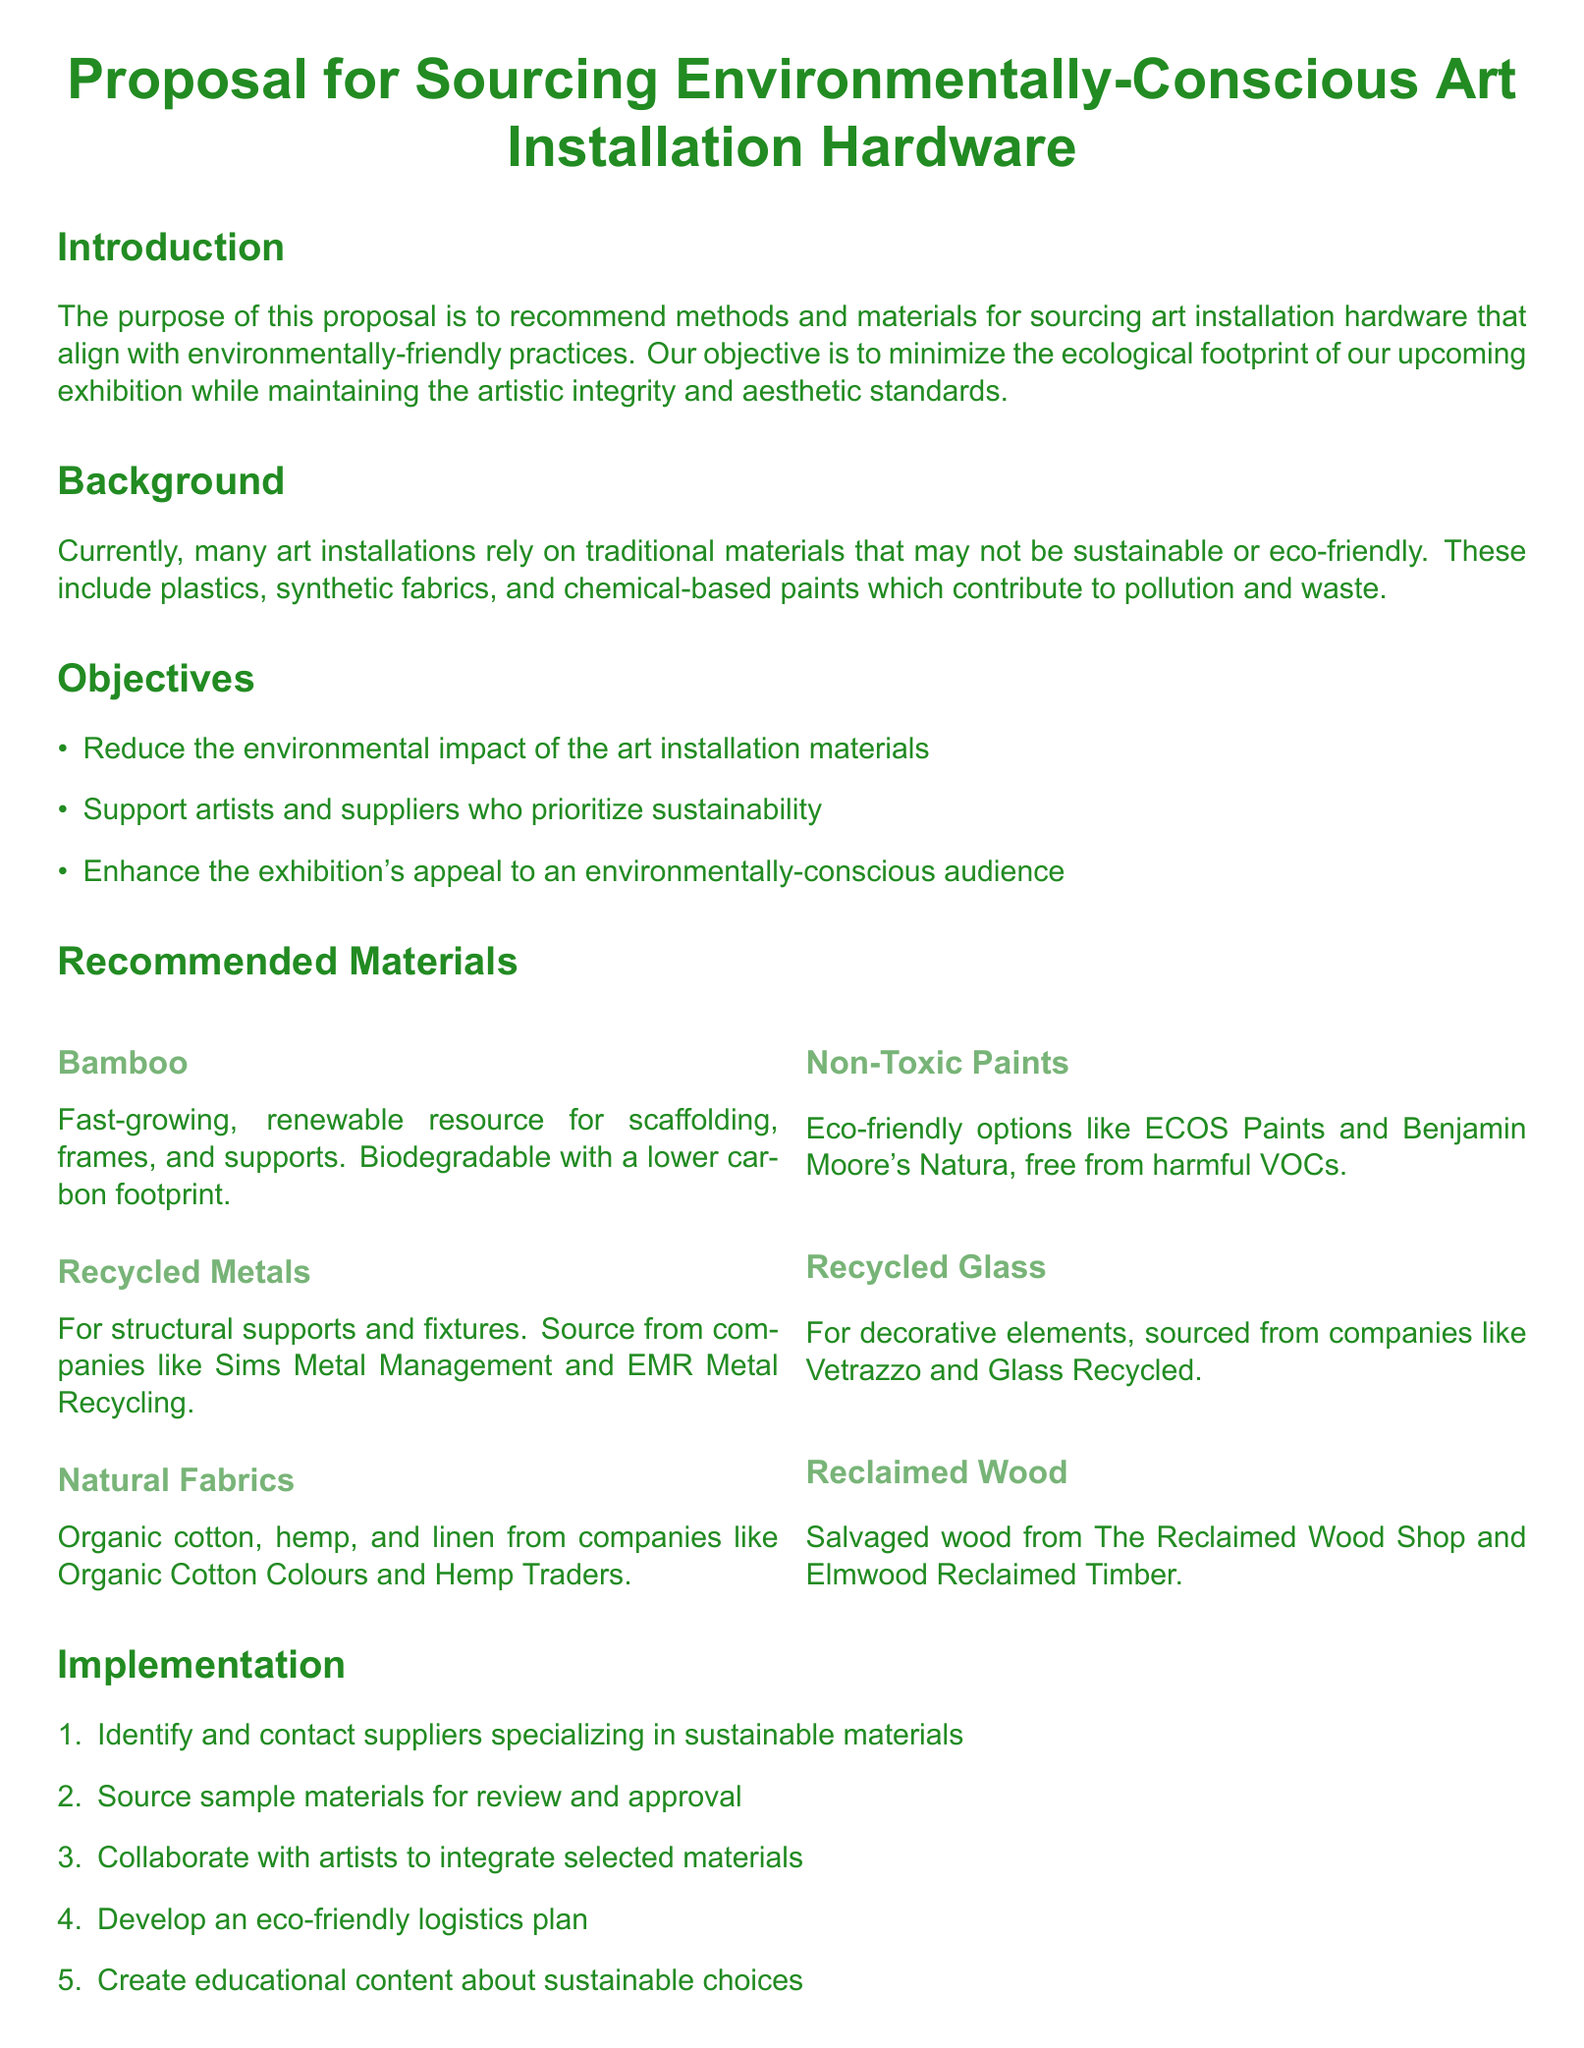What is the main purpose of this proposal? The main purpose of the proposal is to recommend methods and materials for sourcing environmentally-friendly art installation hardware.
Answer: Recommend methods and materials for sourcing environmentally-friendly art installation hardware Which materials are suggested for structural supports? The proposal lists recycled metals as a recommended material for structural supports and fixtures.
Answer: Recycled metals Name one eco-friendly paint option mentioned. The proposal mentions ECOS Paints and Benjamin Moore's Natura as eco-friendly paint options.
Answer: ECOS Paints What type of fabric is recommended? The document recommends using natural fabrics such as organic cotton, hemp, and linen.
Answer: Natural fabrics How many steps are outlined in the implementation section? The implementation section contains five steps for sourcing environmentally-conscious materials.
Answer: Five steps What is one expected outcome of the proposal? One expected outcome mentioned is an enhanced reputation as a sustainability leader.
Answer: Enhanced reputation as a sustainability leader Who are potential suppliers for natural fabrics? The proposal mentions companies like Organic Cotton Colours and Hemp Traders as suppliers for natural fabrics.
Answer: Organic Cotton Colours and Hemp Traders What is the ecological benefit of using bamboo? The proposal highlights bamboo as a fast-growing, renewable resource that is biodegradable and has a lower carbon footprint.
Answer: Biodegradable and lower carbon footprint What is the overall conclusion of the proposal? The conclusion emphasizes that adopting environmentally-conscious materials for art installations is feasible and impactful.
Answer: Feasible and impactful 